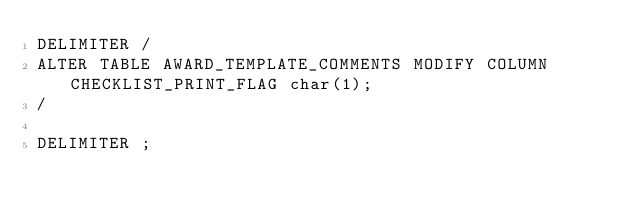Convert code to text. <code><loc_0><loc_0><loc_500><loc_500><_SQL_>DELIMITER /
ALTER TABLE AWARD_TEMPLATE_COMMENTS MODIFY COLUMN CHECKLIST_PRINT_FLAG char(1);
/

DELIMITER ;
</code> 